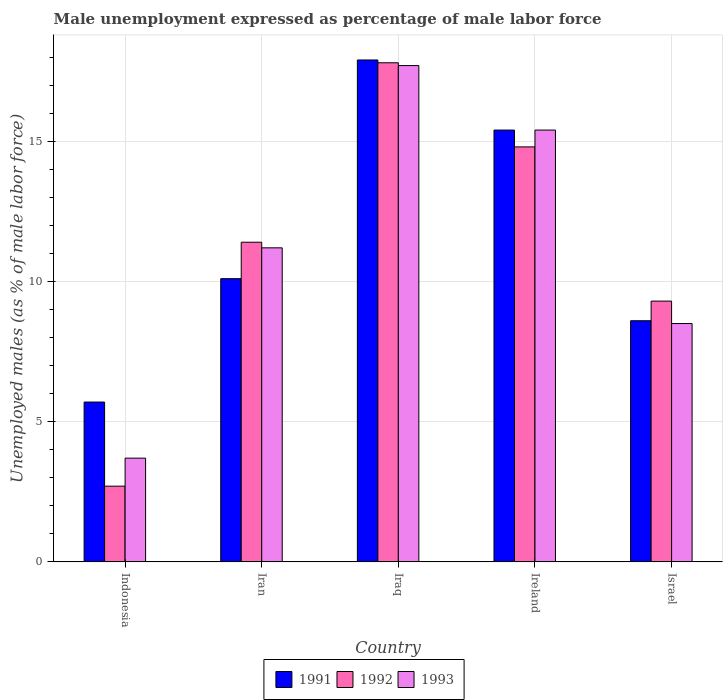How many groups of bars are there?
Offer a terse response. 5. Are the number of bars on each tick of the X-axis equal?
Offer a terse response. Yes. How many bars are there on the 3rd tick from the left?
Keep it short and to the point. 3. How many bars are there on the 1st tick from the right?
Provide a short and direct response. 3. In how many cases, is the number of bars for a given country not equal to the number of legend labels?
Ensure brevity in your answer.  0. What is the unemployment in males in in 1993 in Ireland?
Your answer should be very brief. 15.4. Across all countries, what is the maximum unemployment in males in in 1993?
Provide a short and direct response. 17.7. Across all countries, what is the minimum unemployment in males in in 1993?
Keep it short and to the point. 3.7. In which country was the unemployment in males in in 1993 maximum?
Offer a very short reply. Iraq. What is the total unemployment in males in in 1991 in the graph?
Your response must be concise. 57.7. What is the difference between the unemployment in males in in 1992 in Iran and that in Israel?
Your response must be concise. 2.1. What is the difference between the unemployment in males in in 1993 in Iraq and the unemployment in males in in 1991 in Indonesia?
Provide a succinct answer. 12. What is the average unemployment in males in in 1991 per country?
Provide a succinct answer. 11.54. What is the difference between the unemployment in males in of/in 1993 and unemployment in males in of/in 1992 in Iraq?
Offer a terse response. -0.1. In how many countries, is the unemployment in males in in 1993 greater than 8 %?
Your response must be concise. 4. What is the ratio of the unemployment in males in in 1992 in Indonesia to that in Iraq?
Your response must be concise. 0.15. What is the difference between the highest and the second highest unemployment in males in in 1992?
Offer a very short reply. 6.4. What is the difference between the highest and the lowest unemployment in males in in 1991?
Your answer should be very brief. 12.2. In how many countries, is the unemployment in males in in 1993 greater than the average unemployment in males in in 1993 taken over all countries?
Keep it short and to the point. 2. What does the 3rd bar from the left in Ireland represents?
Keep it short and to the point. 1993. How many bars are there?
Provide a short and direct response. 15. How many countries are there in the graph?
Make the answer very short. 5. Does the graph contain any zero values?
Provide a succinct answer. No. Where does the legend appear in the graph?
Ensure brevity in your answer.  Bottom center. How are the legend labels stacked?
Offer a very short reply. Horizontal. What is the title of the graph?
Keep it short and to the point. Male unemployment expressed as percentage of male labor force. Does "1999" appear as one of the legend labels in the graph?
Your response must be concise. No. What is the label or title of the X-axis?
Make the answer very short. Country. What is the label or title of the Y-axis?
Give a very brief answer. Unemployed males (as % of male labor force). What is the Unemployed males (as % of male labor force) in 1991 in Indonesia?
Provide a short and direct response. 5.7. What is the Unemployed males (as % of male labor force) in 1992 in Indonesia?
Offer a terse response. 2.7. What is the Unemployed males (as % of male labor force) in 1993 in Indonesia?
Your response must be concise. 3.7. What is the Unemployed males (as % of male labor force) of 1991 in Iran?
Offer a very short reply. 10.1. What is the Unemployed males (as % of male labor force) in 1992 in Iran?
Offer a very short reply. 11.4. What is the Unemployed males (as % of male labor force) in 1993 in Iran?
Provide a succinct answer. 11.2. What is the Unemployed males (as % of male labor force) in 1991 in Iraq?
Provide a short and direct response. 17.9. What is the Unemployed males (as % of male labor force) in 1992 in Iraq?
Your answer should be compact. 17.8. What is the Unemployed males (as % of male labor force) in 1993 in Iraq?
Ensure brevity in your answer.  17.7. What is the Unemployed males (as % of male labor force) of 1991 in Ireland?
Offer a very short reply. 15.4. What is the Unemployed males (as % of male labor force) of 1992 in Ireland?
Your response must be concise. 14.8. What is the Unemployed males (as % of male labor force) in 1993 in Ireland?
Your answer should be very brief. 15.4. What is the Unemployed males (as % of male labor force) in 1991 in Israel?
Your answer should be very brief. 8.6. What is the Unemployed males (as % of male labor force) of 1992 in Israel?
Give a very brief answer. 9.3. Across all countries, what is the maximum Unemployed males (as % of male labor force) of 1991?
Give a very brief answer. 17.9. Across all countries, what is the maximum Unemployed males (as % of male labor force) in 1992?
Your answer should be very brief. 17.8. Across all countries, what is the maximum Unemployed males (as % of male labor force) of 1993?
Make the answer very short. 17.7. Across all countries, what is the minimum Unemployed males (as % of male labor force) of 1991?
Keep it short and to the point. 5.7. Across all countries, what is the minimum Unemployed males (as % of male labor force) of 1992?
Give a very brief answer. 2.7. Across all countries, what is the minimum Unemployed males (as % of male labor force) of 1993?
Give a very brief answer. 3.7. What is the total Unemployed males (as % of male labor force) in 1991 in the graph?
Your answer should be very brief. 57.7. What is the total Unemployed males (as % of male labor force) of 1992 in the graph?
Your answer should be compact. 56. What is the total Unemployed males (as % of male labor force) of 1993 in the graph?
Keep it short and to the point. 56.5. What is the difference between the Unemployed males (as % of male labor force) of 1992 in Indonesia and that in Iran?
Offer a terse response. -8.7. What is the difference between the Unemployed males (as % of male labor force) in 1993 in Indonesia and that in Iran?
Provide a succinct answer. -7.5. What is the difference between the Unemployed males (as % of male labor force) of 1992 in Indonesia and that in Iraq?
Offer a terse response. -15.1. What is the difference between the Unemployed males (as % of male labor force) in 1992 in Indonesia and that in Ireland?
Ensure brevity in your answer.  -12.1. What is the difference between the Unemployed males (as % of male labor force) in 1991 in Indonesia and that in Israel?
Provide a succinct answer. -2.9. What is the difference between the Unemployed males (as % of male labor force) of 1993 in Indonesia and that in Israel?
Keep it short and to the point. -4.8. What is the difference between the Unemployed males (as % of male labor force) of 1991 in Iran and that in Iraq?
Keep it short and to the point. -7.8. What is the difference between the Unemployed males (as % of male labor force) of 1993 in Iran and that in Iraq?
Your answer should be compact. -6.5. What is the difference between the Unemployed males (as % of male labor force) in 1992 in Iran and that in Ireland?
Offer a terse response. -3.4. What is the difference between the Unemployed males (as % of male labor force) of 1993 in Iran and that in Israel?
Offer a terse response. 2.7. What is the difference between the Unemployed males (as % of male labor force) in 1991 in Iraq and that in Ireland?
Make the answer very short. 2.5. What is the difference between the Unemployed males (as % of male labor force) of 1992 in Iraq and that in Ireland?
Provide a succinct answer. 3. What is the difference between the Unemployed males (as % of male labor force) in 1991 in Iraq and that in Israel?
Make the answer very short. 9.3. What is the difference between the Unemployed males (as % of male labor force) in 1993 in Iraq and that in Israel?
Provide a succinct answer. 9.2. What is the difference between the Unemployed males (as % of male labor force) in 1993 in Ireland and that in Israel?
Ensure brevity in your answer.  6.9. What is the difference between the Unemployed males (as % of male labor force) of 1991 in Indonesia and the Unemployed males (as % of male labor force) of 1992 in Iraq?
Keep it short and to the point. -12.1. What is the difference between the Unemployed males (as % of male labor force) of 1992 in Indonesia and the Unemployed males (as % of male labor force) of 1993 in Israel?
Provide a short and direct response. -5.8. What is the difference between the Unemployed males (as % of male labor force) of 1991 in Iran and the Unemployed males (as % of male labor force) of 1993 in Iraq?
Keep it short and to the point. -7.6. What is the difference between the Unemployed males (as % of male labor force) in 1992 in Iran and the Unemployed males (as % of male labor force) in 1993 in Iraq?
Ensure brevity in your answer.  -6.3. What is the difference between the Unemployed males (as % of male labor force) in 1991 in Iran and the Unemployed males (as % of male labor force) in 1992 in Ireland?
Offer a terse response. -4.7. What is the difference between the Unemployed males (as % of male labor force) in 1991 in Iran and the Unemployed males (as % of male labor force) in 1993 in Ireland?
Offer a very short reply. -5.3. What is the difference between the Unemployed males (as % of male labor force) in 1992 in Iran and the Unemployed males (as % of male labor force) in 1993 in Ireland?
Offer a terse response. -4. What is the difference between the Unemployed males (as % of male labor force) of 1991 in Iran and the Unemployed males (as % of male labor force) of 1992 in Israel?
Your response must be concise. 0.8. What is the difference between the Unemployed males (as % of male labor force) in 1992 in Iran and the Unemployed males (as % of male labor force) in 1993 in Israel?
Ensure brevity in your answer.  2.9. What is the difference between the Unemployed males (as % of male labor force) of 1991 in Iraq and the Unemployed males (as % of male labor force) of 1992 in Israel?
Offer a terse response. 8.6. What is the difference between the Unemployed males (as % of male labor force) in 1991 in Iraq and the Unemployed males (as % of male labor force) in 1993 in Israel?
Provide a succinct answer. 9.4. What is the difference between the Unemployed males (as % of male labor force) of 1992 in Iraq and the Unemployed males (as % of male labor force) of 1993 in Israel?
Provide a succinct answer. 9.3. What is the difference between the Unemployed males (as % of male labor force) of 1991 in Ireland and the Unemployed males (as % of male labor force) of 1993 in Israel?
Keep it short and to the point. 6.9. What is the difference between the Unemployed males (as % of male labor force) in 1992 in Ireland and the Unemployed males (as % of male labor force) in 1993 in Israel?
Your response must be concise. 6.3. What is the average Unemployed males (as % of male labor force) in 1991 per country?
Provide a succinct answer. 11.54. What is the average Unemployed males (as % of male labor force) of 1993 per country?
Your answer should be very brief. 11.3. What is the difference between the Unemployed males (as % of male labor force) of 1991 and Unemployed males (as % of male labor force) of 1993 in Indonesia?
Provide a succinct answer. 2. What is the difference between the Unemployed males (as % of male labor force) in 1991 and Unemployed males (as % of male labor force) in 1993 in Iran?
Keep it short and to the point. -1.1. What is the difference between the Unemployed males (as % of male labor force) of 1992 and Unemployed males (as % of male labor force) of 1993 in Iraq?
Your answer should be very brief. 0.1. What is the ratio of the Unemployed males (as % of male labor force) of 1991 in Indonesia to that in Iran?
Provide a short and direct response. 0.56. What is the ratio of the Unemployed males (as % of male labor force) of 1992 in Indonesia to that in Iran?
Offer a terse response. 0.24. What is the ratio of the Unemployed males (as % of male labor force) in 1993 in Indonesia to that in Iran?
Provide a short and direct response. 0.33. What is the ratio of the Unemployed males (as % of male labor force) in 1991 in Indonesia to that in Iraq?
Your answer should be very brief. 0.32. What is the ratio of the Unemployed males (as % of male labor force) in 1992 in Indonesia to that in Iraq?
Provide a short and direct response. 0.15. What is the ratio of the Unemployed males (as % of male labor force) of 1993 in Indonesia to that in Iraq?
Provide a succinct answer. 0.21. What is the ratio of the Unemployed males (as % of male labor force) of 1991 in Indonesia to that in Ireland?
Give a very brief answer. 0.37. What is the ratio of the Unemployed males (as % of male labor force) of 1992 in Indonesia to that in Ireland?
Your answer should be compact. 0.18. What is the ratio of the Unemployed males (as % of male labor force) in 1993 in Indonesia to that in Ireland?
Offer a very short reply. 0.24. What is the ratio of the Unemployed males (as % of male labor force) of 1991 in Indonesia to that in Israel?
Provide a succinct answer. 0.66. What is the ratio of the Unemployed males (as % of male labor force) of 1992 in Indonesia to that in Israel?
Your answer should be compact. 0.29. What is the ratio of the Unemployed males (as % of male labor force) of 1993 in Indonesia to that in Israel?
Your response must be concise. 0.44. What is the ratio of the Unemployed males (as % of male labor force) in 1991 in Iran to that in Iraq?
Your answer should be very brief. 0.56. What is the ratio of the Unemployed males (as % of male labor force) in 1992 in Iran to that in Iraq?
Keep it short and to the point. 0.64. What is the ratio of the Unemployed males (as % of male labor force) in 1993 in Iran to that in Iraq?
Offer a very short reply. 0.63. What is the ratio of the Unemployed males (as % of male labor force) of 1991 in Iran to that in Ireland?
Your answer should be very brief. 0.66. What is the ratio of the Unemployed males (as % of male labor force) in 1992 in Iran to that in Ireland?
Make the answer very short. 0.77. What is the ratio of the Unemployed males (as % of male labor force) of 1993 in Iran to that in Ireland?
Give a very brief answer. 0.73. What is the ratio of the Unemployed males (as % of male labor force) of 1991 in Iran to that in Israel?
Provide a short and direct response. 1.17. What is the ratio of the Unemployed males (as % of male labor force) in 1992 in Iran to that in Israel?
Keep it short and to the point. 1.23. What is the ratio of the Unemployed males (as % of male labor force) of 1993 in Iran to that in Israel?
Keep it short and to the point. 1.32. What is the ratio of the Unemployed males (as % of male labor force) of 1991 in Iraq to that in Ireland?
Give a very brief answer. 1.16. What is the ratio of the Unemployed males (as % of male labor force) of 1992 in Iraq to that in Ireland?
Offer a terse response. 1.2. What is the ratio of the Unemployed males (as % of male labor force) of 1993 in Iraq to that in Ireland?
Your answer should be compact. 1.15. What is the ratio of the Unemployed males (as % of male labor force) in 1991 in Iraq to that in Israel?
Your answer should be compact. 2.08. What is the ratio of the Unemployed males (as % of male labor force) in 1992 in Iraq to that in Israel?
Provide a short and direct response. 1.91. What is the ratio of the Unemployed males (as % of male labor force) of 1993 in Iraq to that in Israel?
Offer a very short reply. 2.08. What is the ratio of the Unemployed males (as % of male labor force) of 1991 in Ireland to that in Israel?
Provide a succinct answer. 1.79. What is the ratio of the Unemployed males (as % of male labor force) of 1992 in Ireland to that in Israel?
Keep it short and to the point. 1.59. What is the ratio of the Unemployed males (as % of male labor force) in 1993 in Ireland to that in Israel?
Your answer should be very brief. 1.81. What is the difference between the highest and the second highest Unemployed males (as % of male labor force) of 1993?
Your answer should be compact. 2.3. What is the difference between the highest and the lowest Unemployed males (as % of male labor force) in 1992?
Your answer should be compact. 15.1. 